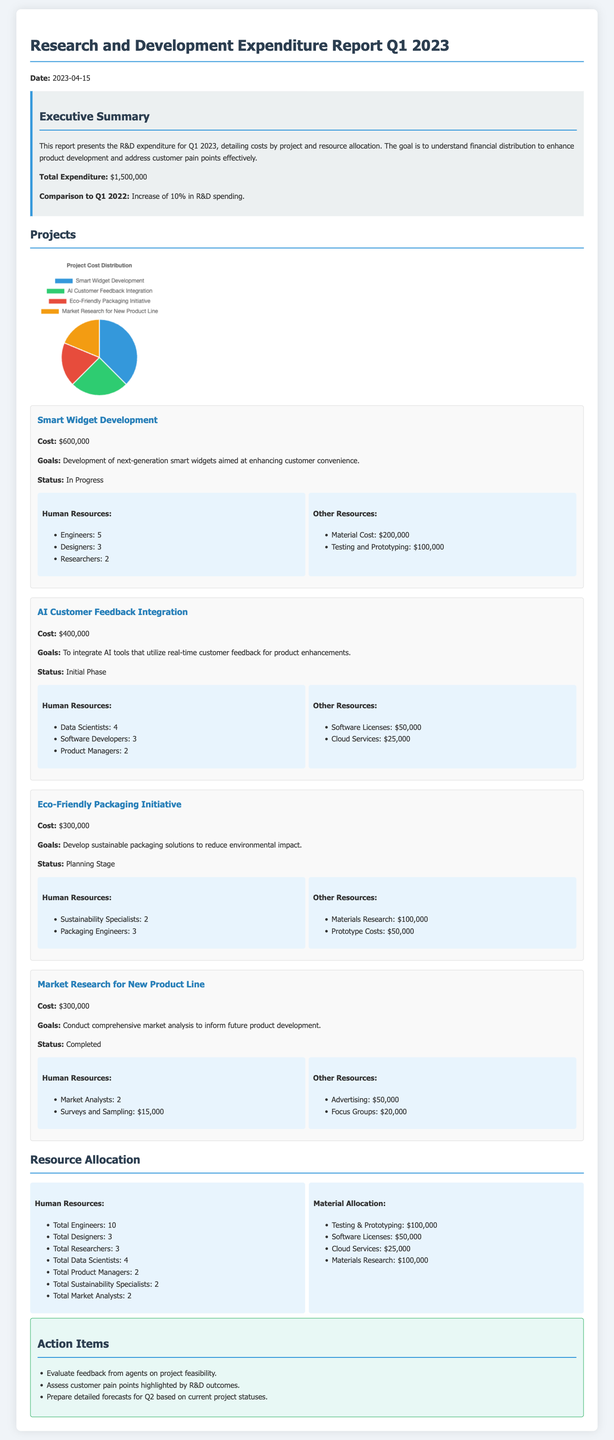What is the total expenditure for Q1 2023? The total expenditure is explicitly stated in the report as $1,500,000.
Answer: $1,500,000 What is the project cost for Smart Widget Development? The report specifies the cost for Smart Widget Development as $600,000.
Answer: $600,000 How many Data Scientists are allocated to the AI Customer Feedback Integration project? The document provides the number of Data Scientists assigned to this project, which is 4.
Answer: 4 What stage is the Eco-Friendly Packaging Initiative currently in? The document states that the Eco-Friendly Packaging Initiative is in the Planning Stage.
Answer: Planning Stage What was the increase in R&D spending compared to Q1 2022? The increase in R&D spending is noted as 10% in the executive summary.
Answer: 10% Which project has the lowest cost? The Eco-Friendly Packaging Initiative and Market Research for New Product Line both have a cost of $300,000, which is the lowest among the projects listed.
Answer: $300,000 How many Engineers are involved across all projects? The report states the total number of Engineers is 10.
Answer: 10 What is the goal of the AI Customer Feedback Integration project? The document outlines that the goal is to integrate AI tools that utilize real-time customer feedback for product enhancements.
Answer: Integrate AI tools for feedback What is one action item mentioned in the report? The report lists evaluating feedback from agents on project feasibility as one of the action items.
Answer: Evaluate feedback from agents 